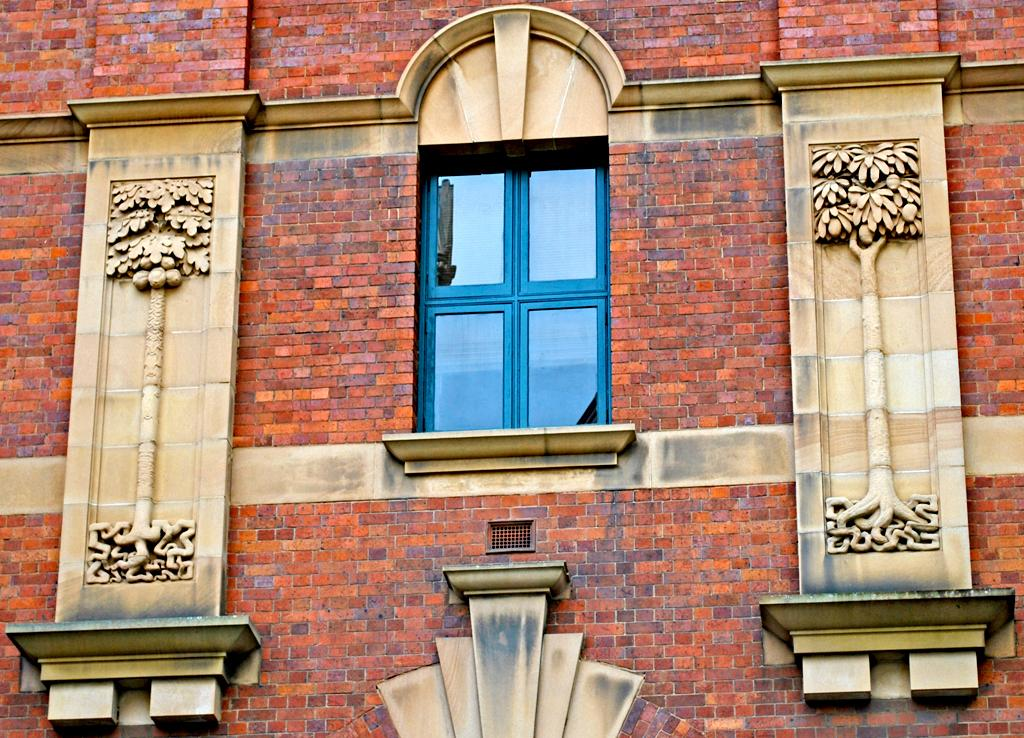What color is the wall that can be seen in the image? The wall in the image is red. What feature is present in the wall that allows for natural light to enter the room? There is a window in the image. What type of artwork is visible in the image? There are sculptures in the image. What type of wheel can be seen in the image? There is no wheel present in the image. What effect does the red wall have on the mood of the room in the image? The provided facts do not include information about the mood of the room, so it is impossible to determine the effect of the red wall on the mood. 